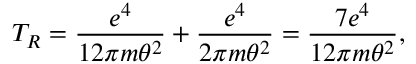Convert formula to latex. <formula><loc_0><loc_0><loc_500><loc_500>T _ { R } = \frac { e ^ { 4 } } { 1 2 \pi m \theta ^ { 2 } } + \frac { e ^ { 4 } } { 2 \pi m \theta ^ { 2 } } = \frac { 7 e ^ { 4 } } { 1 2 \pi m \theta ^ { 2 } } ,</formula> 